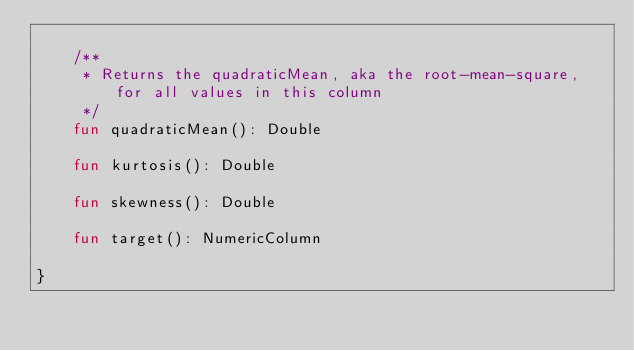<code> <loc_0><loc_0><loc_500><loc_500><_Kotlin_>
    /**
     * Returns the quadraticMean, aka the root-mean-square, for all values in this column
     */
    fun quadraticMean(): Double

    fun kurtosis(): Double

    fun skewness(): Double

    fun target(): NumericColumn

}
</code> 